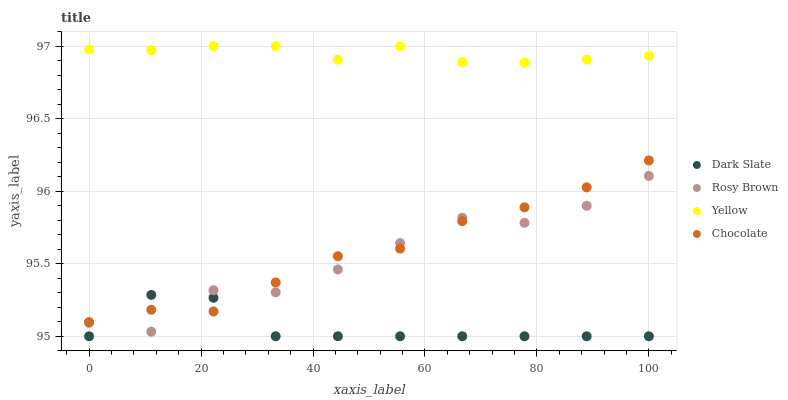Does Dark Slate have the minimum area under the curve?
Answer yes or no. Yes. Does Yellow have the maximum area under the curve?
Answer yes or no. Yes. Does Rosy Brown have the minimum area under the curve?
Answer yes or no. No. Does Rosy Brown have the maximum area under the curve?
Answer yes or no. No. Is Yellow the smoothest?
Answer yes or no. Yes. Is Rosy Brown the roughest?
Answer yes or no. Yes. Is Rosy Brown the smoothest?
Answer yes or no. No. Is Yellow the roughest?
Answer yes or no. No. Does Dark Slate have the lowest value?
Answer yes or no. Yes. Does Rosy Brown have the lowest value?
Answer yes or no. No. Does Yellow have the highest value?
Answer yes or no. Yes. Does Rosy Brown have the highest value?
Answer yes or no. No. Is Chocolate less than Yellow?
Answer yes or no. Yes. Is Yellow greater than Chocolate?
Answer yes or no. Yes. Does Chocolate intersect Rosy Brown?
Answer yes or no. Yes. Is Chocolate less than Rosy Brown?
Answer yes or no. No. Is Chocolate greater than Rosy Brown?
Answer yes or no. No. Does Chocolate intersect Yellow?
Answer yes or no. No. 